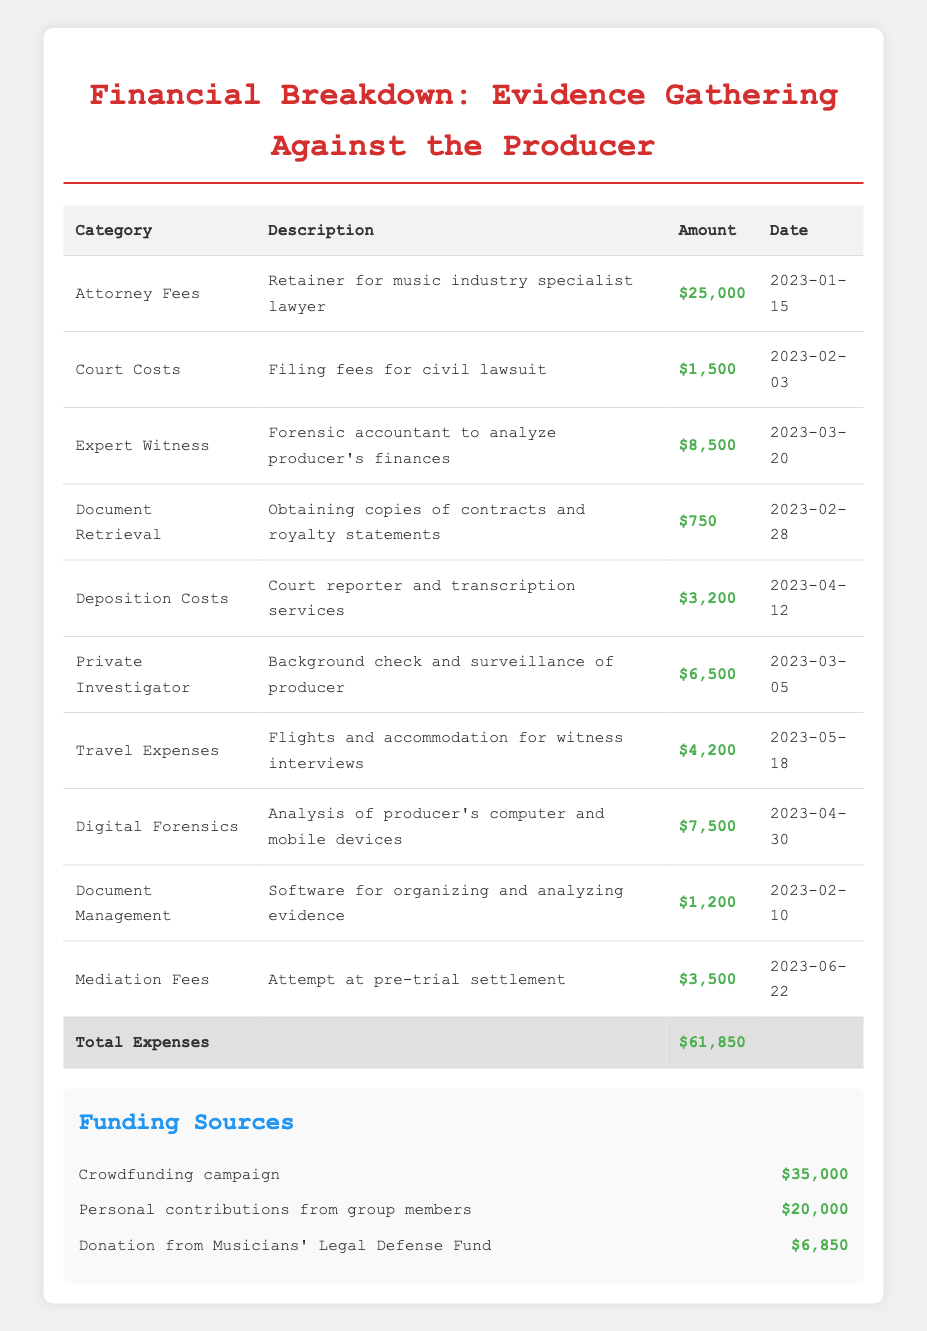What is the total expense for gathering evidence against the producer? The total expense is explicitly listed at the bottom of the table under 'Total Expenses', which states that the amount is $61,850.
Answer: $61,850 Which category has the highest expense amount? By comparing the amounts across all categories, the 'Attorney Fees' category has the highest expense amount of $25,000.
Answer: Attorney Fees How much was spent on expert witness services? The 'Expert Witness' row clearly states that $8,500 was spent on forensic accountant services to analyze the producer's finances.
Answer: $8,500 What is the total amount spent on travel expenses and deposition costs together? To find this, we add the 'Travel Expenses' amount of $4,200 to the 'Deposition Costs' amount of $3,200. Therefore, the total is $4,200 + $3,200 = $7,400.
Answer: $7,400 Did the group receive funding from the Musicians' Legal Defense Fund? Yes, the table shows a funding source labeled 'Donation from Musicians' Legal Defense Fund' with an amount of $6,850, confirming that they did receive funding from this source.
Answer: Yes What is the difference between the highest and lowest legal expense amounts? The highest legal expense is $25,000 (Attorney Fees) and the lowest is $750 (Document Retrieval). The difference is calculated as $25,000 - $750 = $24,250.
Answer: $24,250 How much did the crowdfunding campaign contribute to the legal expenses? The table specifies that the 'Crowdfunding campaign' contributed an amount of $35,000, which is clearly indicated in the funding sources section.
Answer: $35,000 What percentage of the total expenses was covered by personal contributions from group members? First, find the amount from personal contributions, which is $20,000. Then, to find the percentage, we use the formula (20,000 / 61,850) * 100, which equals 32.3%.
Answer: 32.3% How many categories of expenses are listed in the table? By counting the rows under the legal expenses section, there are 10 different expense categories detailed in the table.
Answer: 10 